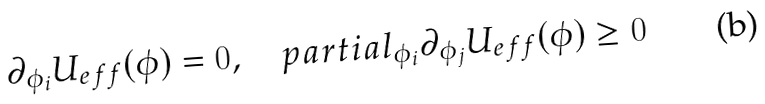<formula> <loc_0><loc_0><loc_500><loc_500>\partial _ { \phi _ { i } } U _ { e f f } ( { \phi } ) = 0 , \quad p a r t i a l _ { \phi _ { i } } \partial _ { \phi _ { j } } U _ { e f f } ( { \phi } ) \geq 0</formula> 